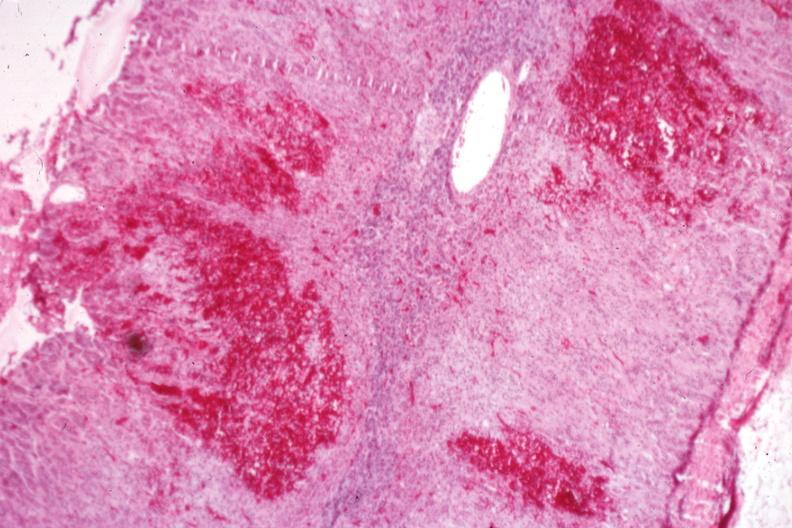does this image show multiple cortical hemorrhages which may be the early stage of a gross adrenal hemorrhage?
Answer the question using a single word or phrase. Yes 